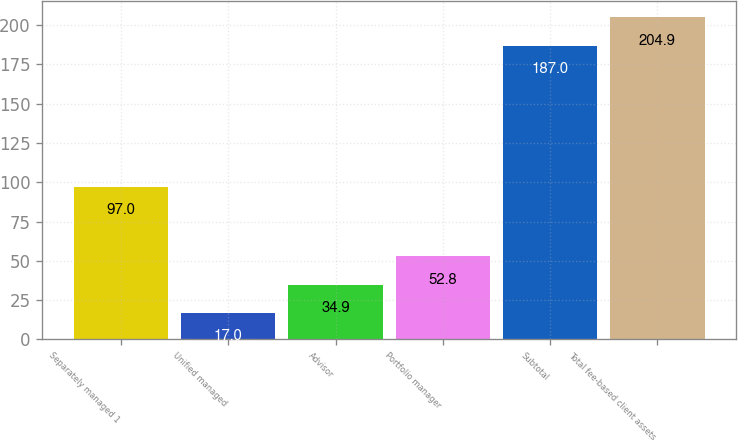Convert chart. <chart><loc_0><loc_0><loc_500><loc_500><bar_chart><fcel>Separately managed 1<fcel>Unified managed<fcel>Advisor<fcel>Portfolio manager<fcel>Subtotal<fcel>Total fee-based client assets<nl><fcel>97<fcel>17<fcel>34.9<fcel>52.8<fcel>187<fcel>204.9<nl></chart> 